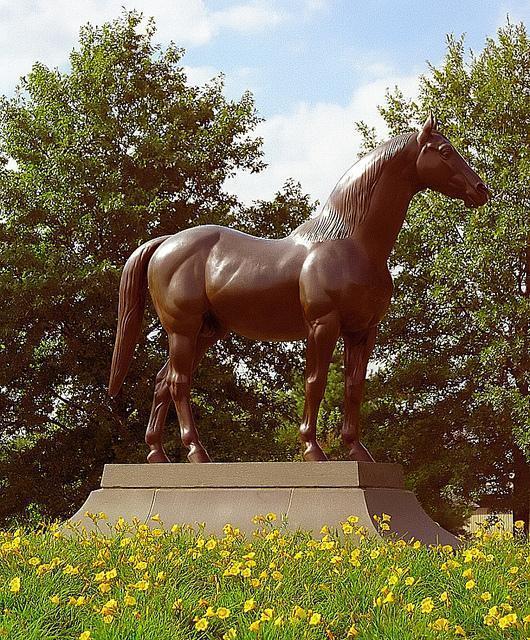How many elephants are there?
Give a very brief answer. 0. 